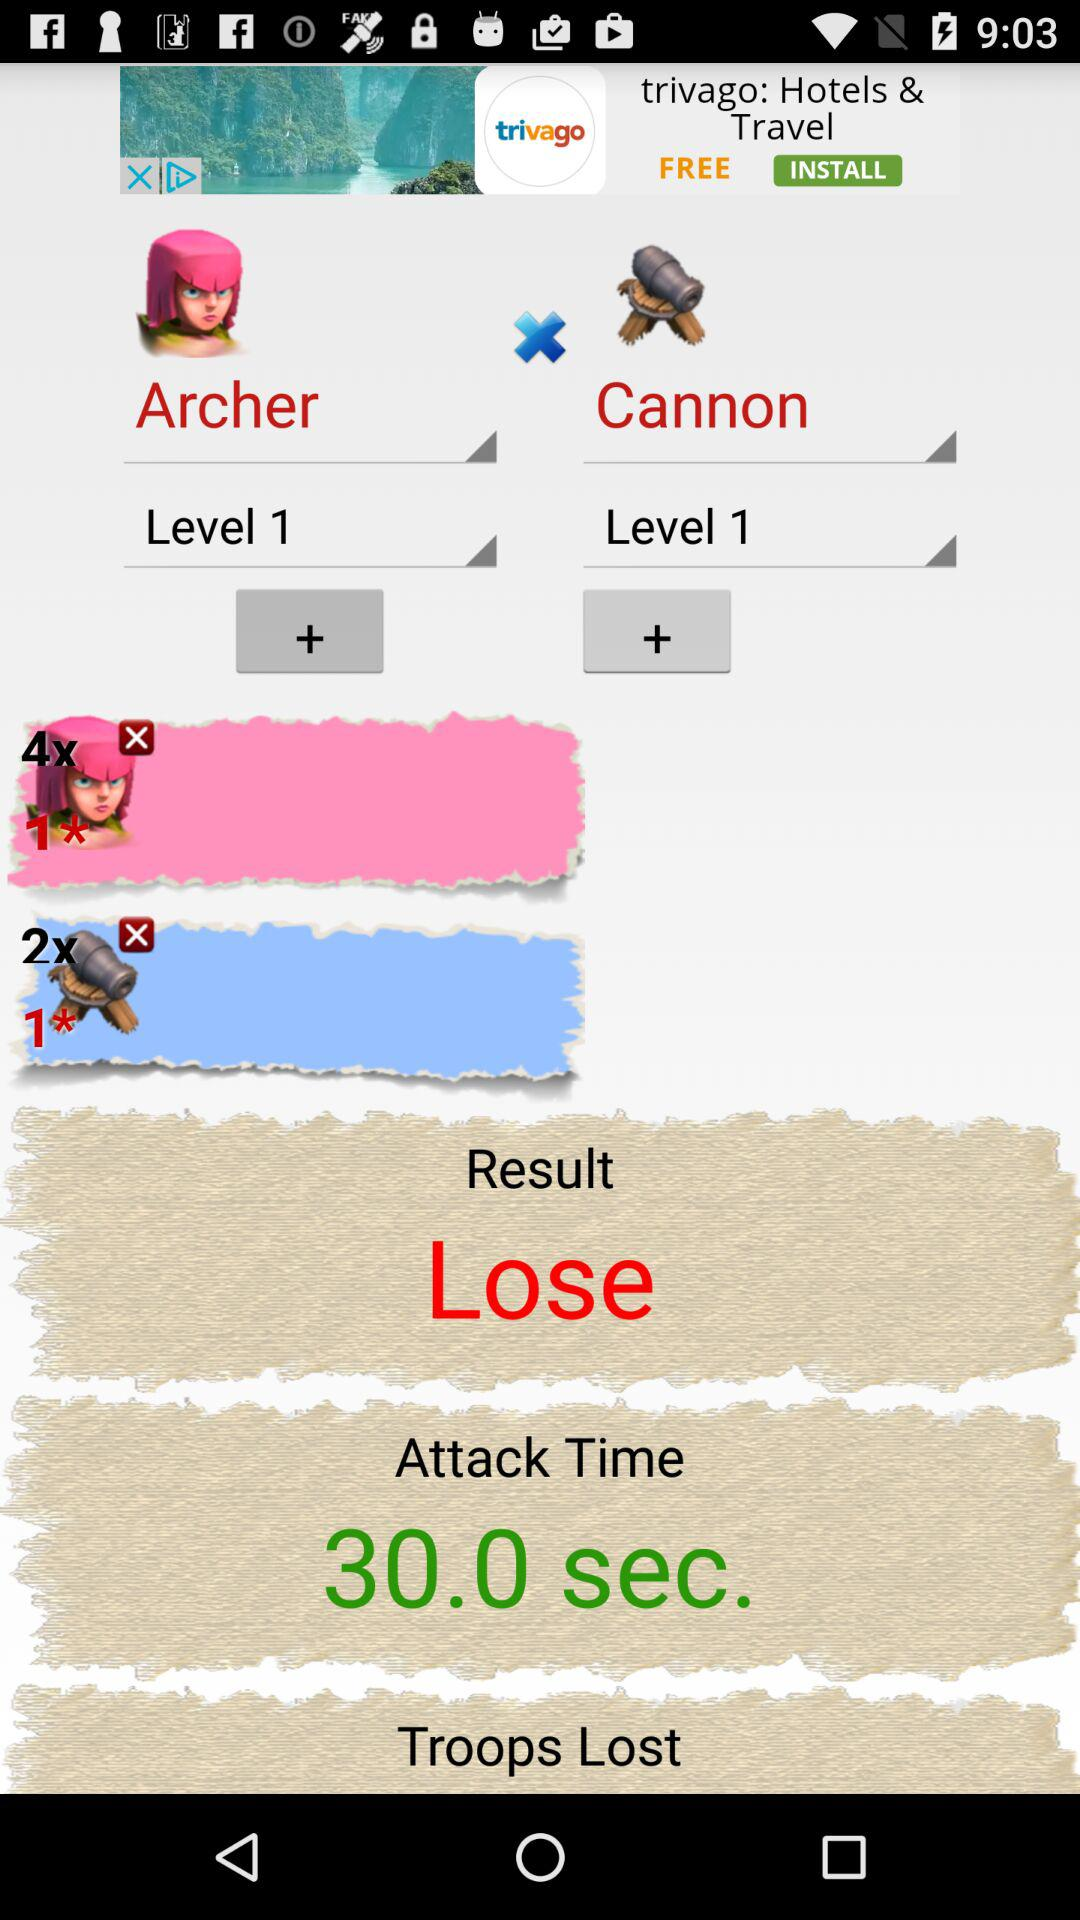What are the name of the players?
When the provided information is insufficient, respond with <no answer>. <no answer> 